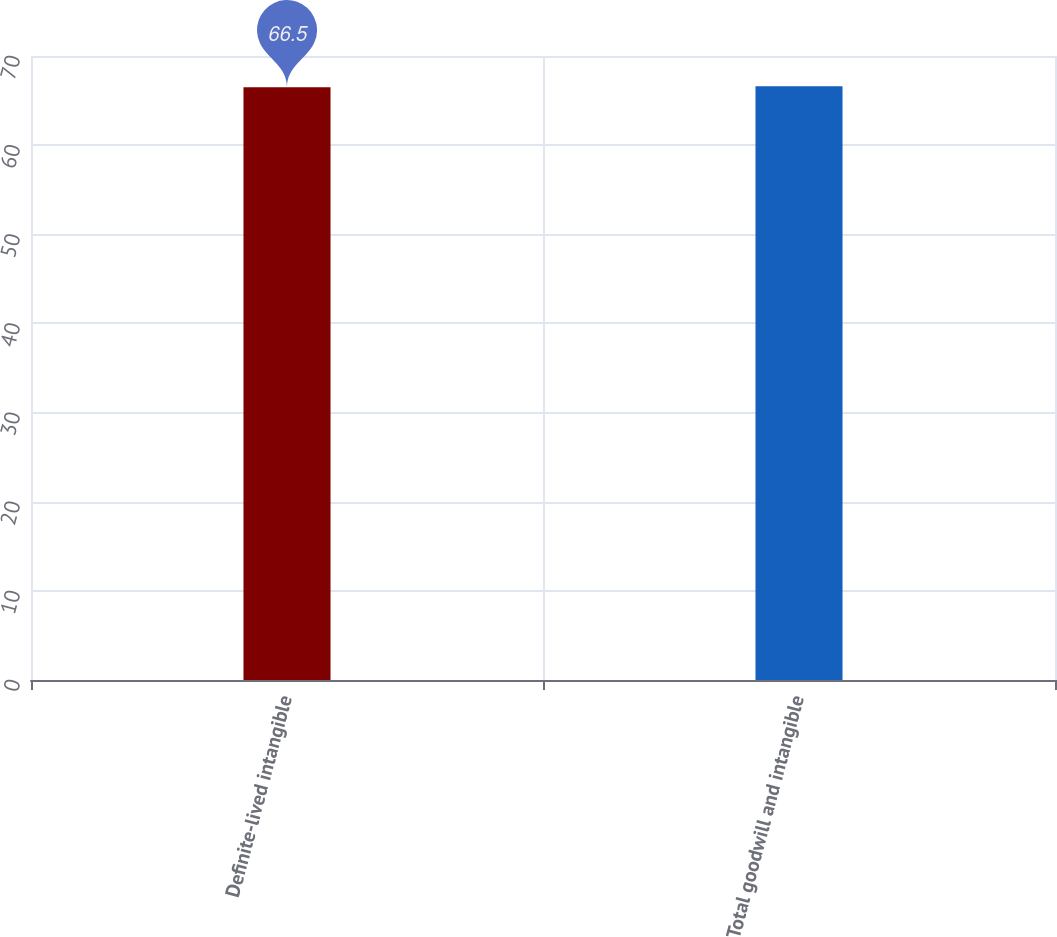Convert chart. <chart><loc_0><loc_0><loc_500><loc_500><bar_chart><fcel>Definite-lived intangible<fcel>Total goodwill and intangible<nl><fcel>66.5<fcel>66.6<nl></chart> 